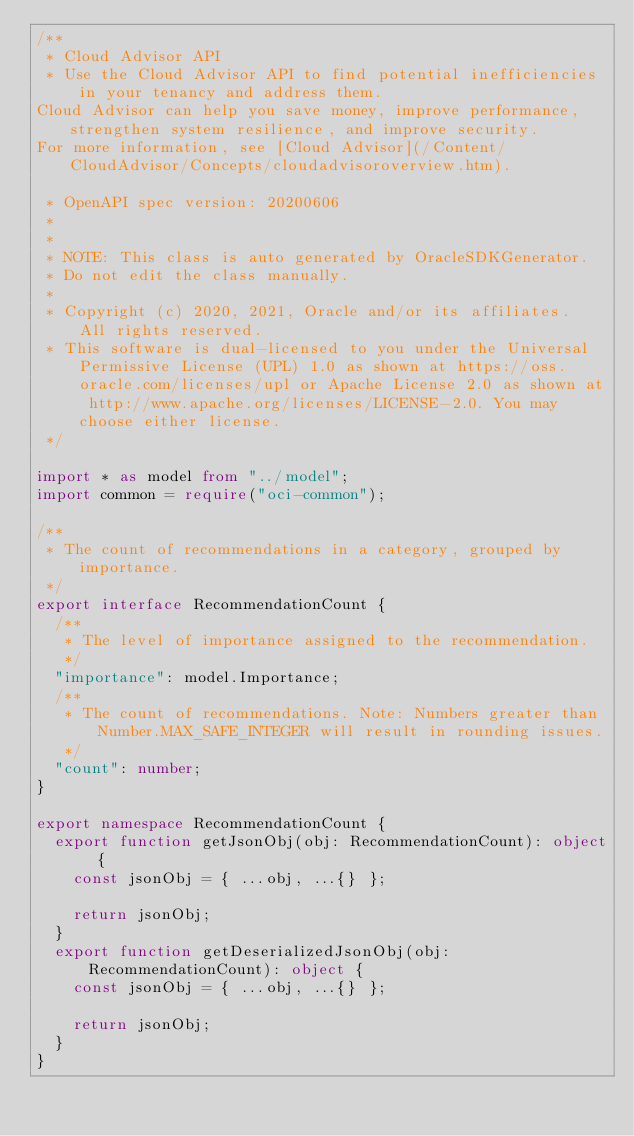Convert code to text. <code><loc_0><loc_0><loc_500><loc_500><_TypeScript_>/**
 * Cloud Advisor API
 * Use the Cloud Advisor API to find potential inefficiencies in your tenancy and address them.
Cloud Advisor can help you save money, improve performance, strengthen system resilience, and improve security.
For more information, see [Cloud Advisor](/Content/CloudAdvisor/Concepts/cloudadvisoroverview.htm).

 * OpenAPI spec version: 20200606
 * 
 *
 * NOTE: This class is auto generated by OracleSDKGenerator.
 * Do not edit the class manually.
 *
 * Copyright (c) 2020, 2021, Oracle and/or its affiliates.  All rights reserved.
 * This software is dual-licensed to you under the Universal Permissive License (UPL) 1.0 as shown at https://oss.oracle.com/licenses/upl or Apache License 2.0 as shown at http://www.apache.org/licenses/LICENSE-2.0. You may choose either license.
 */

import * as model from "../model";
import common = require("oci-common");

/**
 * The count of recommendations in a category, grouped by importance.
 */
export interface RecommendationCount {
  /**
   * The level of importance assigned to the recommendation.
   */
  "importance": model.Importance;
  /**
   * The count of recommendations. Note: Numbers greater than Number.MAX_SAFE_INTEGER will result in rounding issues.
   */
  "count": number;
}

export namespace RecommendationCount {
  export function getJsonObj(obj: RecommendationCount): object {
    const jsonObj = { ...obj, ...{} };

    return jsonObj;
  }
  export function getDeserializedJsonObj(obj: RecommendationCount): object {
    const jsonObj = { ...obj, ...{} };

    return jsonObj;
  }
}
</code> 